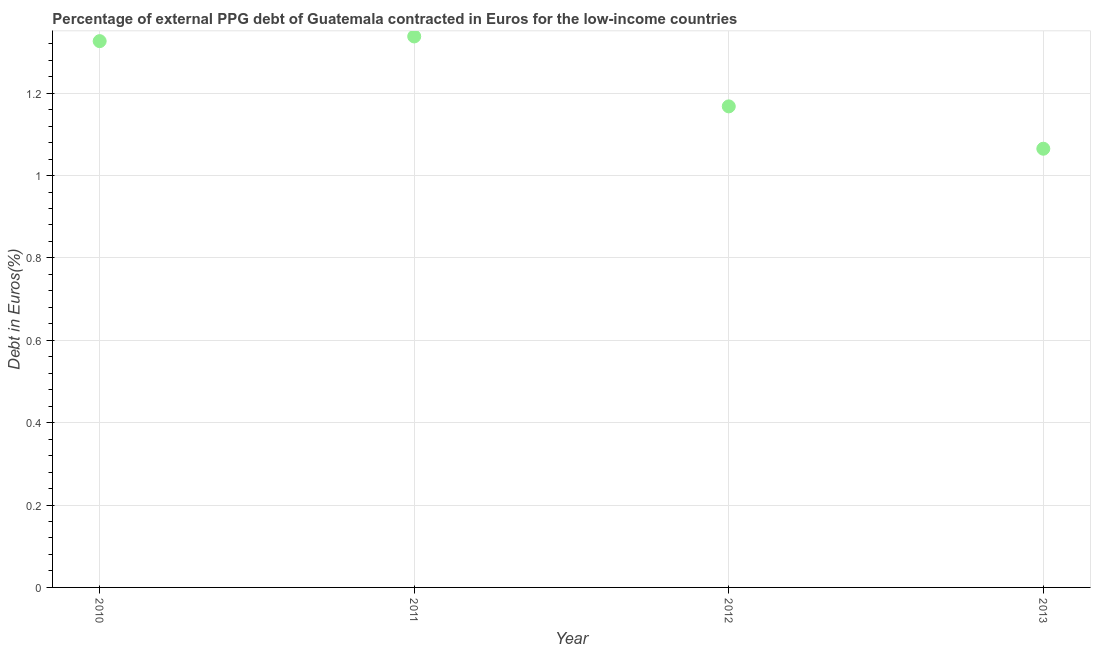What is the currency composition of ppg debt in 2012?
Make the answer very short. 1.17. Across all years, what is the maximum currency composition of ppg debt?
Your answer should be very brief. 1.34. Across all years, what is the minimum currency composition of ppg debt?
Offer a terse response. 1.07. What is the sum of the currency composition of ppg debt?
Provide a succinct answer. 4.9. What is the difference between the currency composition of ppg debt in 2011 and 2013?
Offer a very short reply. 0.27. What is the average currency composition of ppg debt per year?
Provide a succinct answer. 1.22. What is the median currency composition of ppg debt?
Keep it short and to the point. 1.25. In how many years, is the currency composition of ppg debt greater than 0.68 %?
Offer a very short reply. 4. What is the ratio of the currency composition of ppg debt in 2010 to that in 2013?
Your response must be concise. 1.25. Is the difference between the currency composition of ppg debt in 2010 and 2013 greater than the difference between any two years?
Your response must be concise. No. What is the difference between the highest and the second highest currency composition of ppg debt?
Ensure brevity in your answer.  0.01. Is the sum of the currency composition of ppg debt in 2010 and 2012 greater than the maximum currency composition of ppg debt across all years?
Ensure brevity in your answer.  Yes. What is the difference between the highest and the lowest currency composition of ppg debt?
Provide a succinct answer. 0.27. How many years are there in the graph?
Provide a short and direct response. 4. What is the difference between two consecutive major ticks on the Y-axis?
Your response must be concise. 0.2. Does the graph contain any zero values?
Offer a terse response. No. What is the title of the graph?
Give a very brief answer. Percentage of external PPG debt of Guatemala contracted in Euros for the low-income countries. What is the label or title of the Y-axis?
Your answer should be very brief. Debt in Euros(%). What is the Debt in Euros(%) in 2010?
Your answer should be very brief. 1.33. What is the Debt in Euros(%) in 2011?
Make the answer very short. 1.34. What is the Debt in Euros(%) in 2012?
Provide a succinct answer. 1.17. What is the Debt in Euros(%) in 2013?
Offer a very short reply. 1.07. What is the difference between the Debt in Euros(%) in 2010 and 2011?
Offer a very short reply. -0.01. What is the difference between the Debt in Euros(%) in 2010 and 2012?
Ensure brevity in your answer.  0.16. What is the difference between the Debt in Euros(%) in 2010 and 2013?
Offer a very short reply. 0.26. What is the difference between the Debt in Euros(%) in 2011 and 2012?
Offer a very short reply. 0.17. What is the difference between the Debt in Euros(%) in 2011 and 2013?
Offer a terse response. 0.27. What is the difference between the Debt in Euros(%) in 2012 and 2013?
Give a very brief answer. 0.1. What is the ratio of the Debt in Euros(%) in 2010 to that in 2012?
Give a very brief answer. 1.14. What is the ratio of the Debt in Euros(%) in 2010 to that in 2013?
Offer a terse response. 1.25. What is the ratio of the Debt in Euros(%) in 2011 to that in 2012?
Offer a terse response. 1.15. What is the ratio of the Debt in Euros(%) in 2011 to that in 2013?
Your answer should be compact. 1.26. What is the ratio of the Debt in Euros(%) in 2012 to that in 2013?
Give a very brief answer. 1.1. 